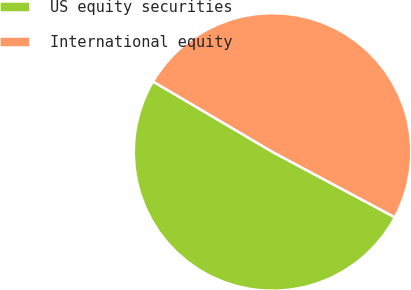Convert chart. <chart><loc_0><loc_0><loc_500><loc_500><pie_chart><fcel>US equity securities<fcel>International equity<nl><fcel>50.67%<fcel>49.33%<nl></chart> 